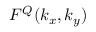<formula> <loc_0><loc_0><loc_500><loc_500>F ^ { Q } ( k _ { x } , k _ { y } )</formula> 